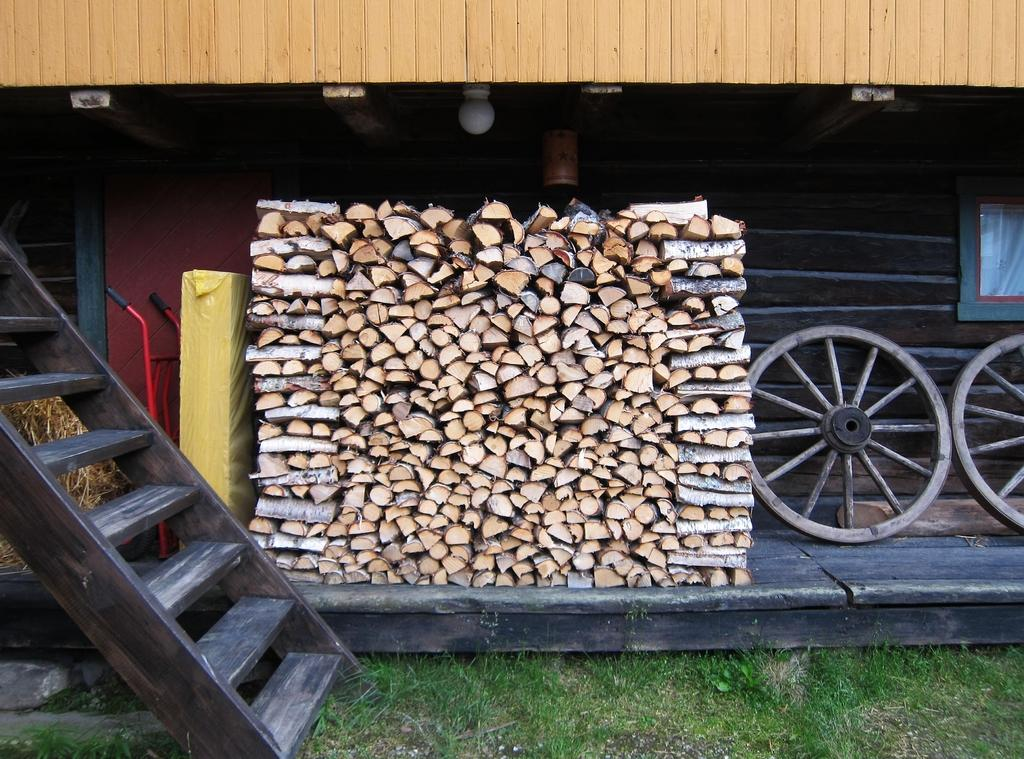What type of structure is partially visible in the image? There is a part of a building in the image. What objects are made of wood in the image? There are wooden sticks in the image. What type of container is present in the image? There is a box with a cover in the image. What is used to support or hold something in the image? There is a stand in the image. What type of natural environment is visible in the image? There is grass in the image. What type of transportation-related object is present in the image? There are wheels in the image. What type of equipment is used for climbing in the image? There is a ladder in the image. What type of illumination is present at the top of the image? There is a light at the top of the image. What type of berry is growing on the ladder in the image? There are no berries present in the image, and the ladder is not a plant or a location where berries would grow. What type of bone is visible in the image? There are no bones present in the image. 